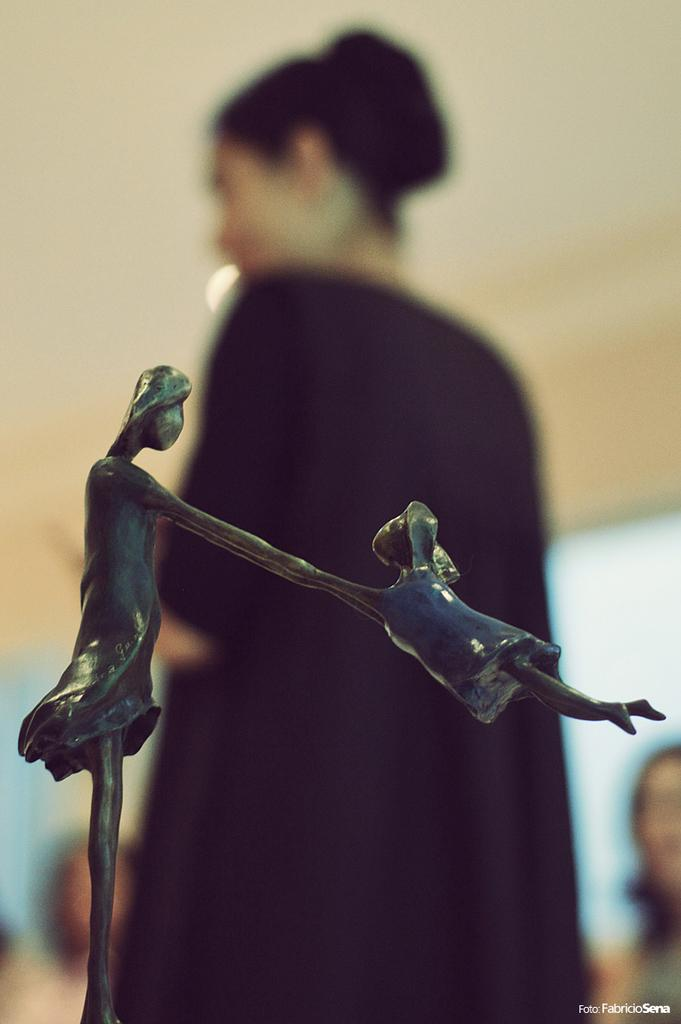What type of structure is present in the image? There is a metal structure in the image. Can you describe the woman's position in relation to the metal structure? The woman is standing behind the metal structure. What type of key is the woman holding in the image? There is no key present in the image; it only features a metal structure and a woman standing behind it. 